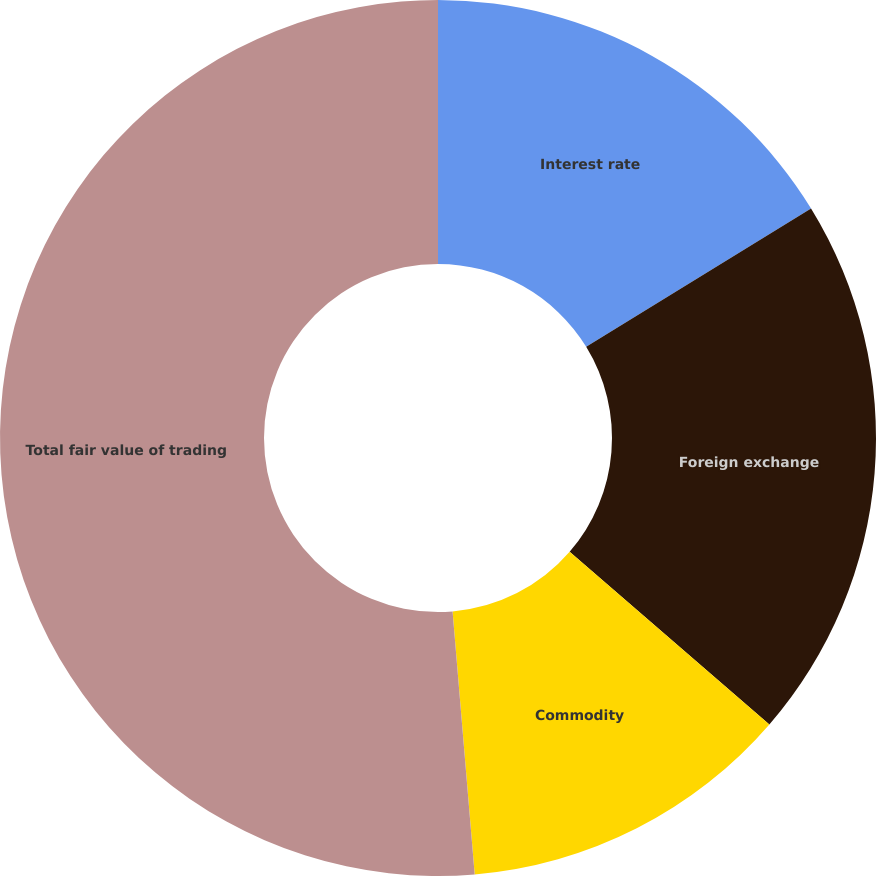Convert chart to OTSL. <chart><loc_0><loc_0><loc_500><loc_500><pie_chart><fcel>Interest rate<fcel>Foreign exchange<fcel>Commodity<fcel>Total fair value of trading<nl><fcel>16.22%<fcel>20.12%<fcel>12.32%<fcel>51.33%<nl></chart> 